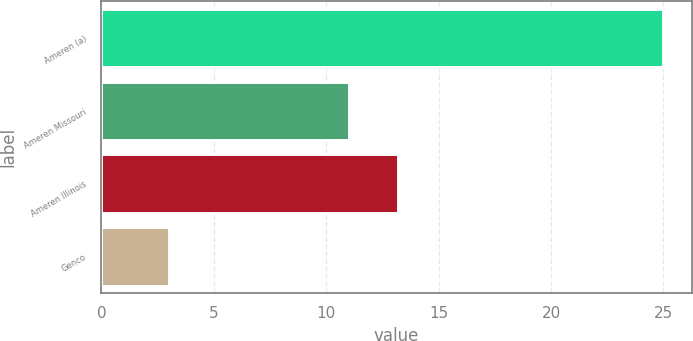Convert chart to OTSL. <chart><loc_0><loc_0><loc_500><loc_500><bar_chart><fcel>Ameren (a)<fcel>Ameren Missouri<fcel>Ameren Illinois<fcel>Genco<nl><fcel>25<fcel>11<fcel>13.2<fcel>3<nl></chart> 